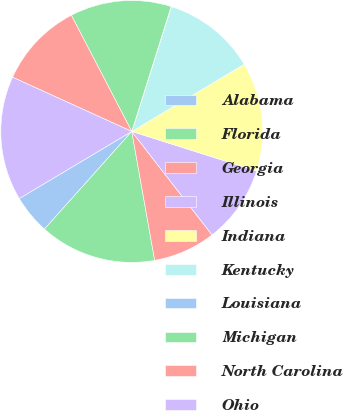<chart> <loc_0><loc_0><loc_500><loc_500><pie_chart><fcel>Alabama<fcel>Florida<fcel>Georgia<fcel>Illinois<fcel>Indiana<fcel>Kentucky<fcel>Louisiana<fcel>Michigan<fcel>North Carolina<fcel>Ohio<nl><fcel>4.83%<fcel>14.41%<fcel>7.7%<fcel>9.62%<fcel>13.45%<fcel>11.53%<fcel>0.04%<fcel>12.49%<fcel>10.57%<fcel>15.36%<nl></chart> 